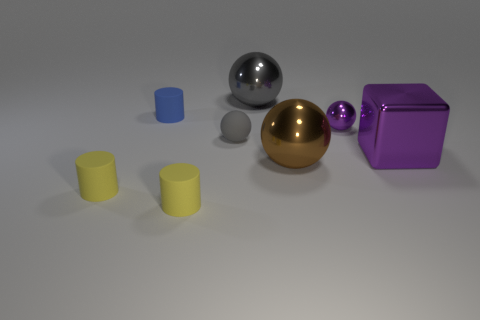How many gray spheres must be subtracted to get 1 gray spheres? 1 Add 1 yellow matte cylinders. How many objects exist? 9 Subtract all blocks. How many objects are left? 7 Subtract all tiny yellow matte objects. Subtract all small metal spheres. How many objects are left? 5 Add 1 gray matte things. How many gray matte things are left? 2 Add 1 blue cylinders. How many blue cylinders exist? 2 Subtract 1 purple balls. How many objects are left? 7 